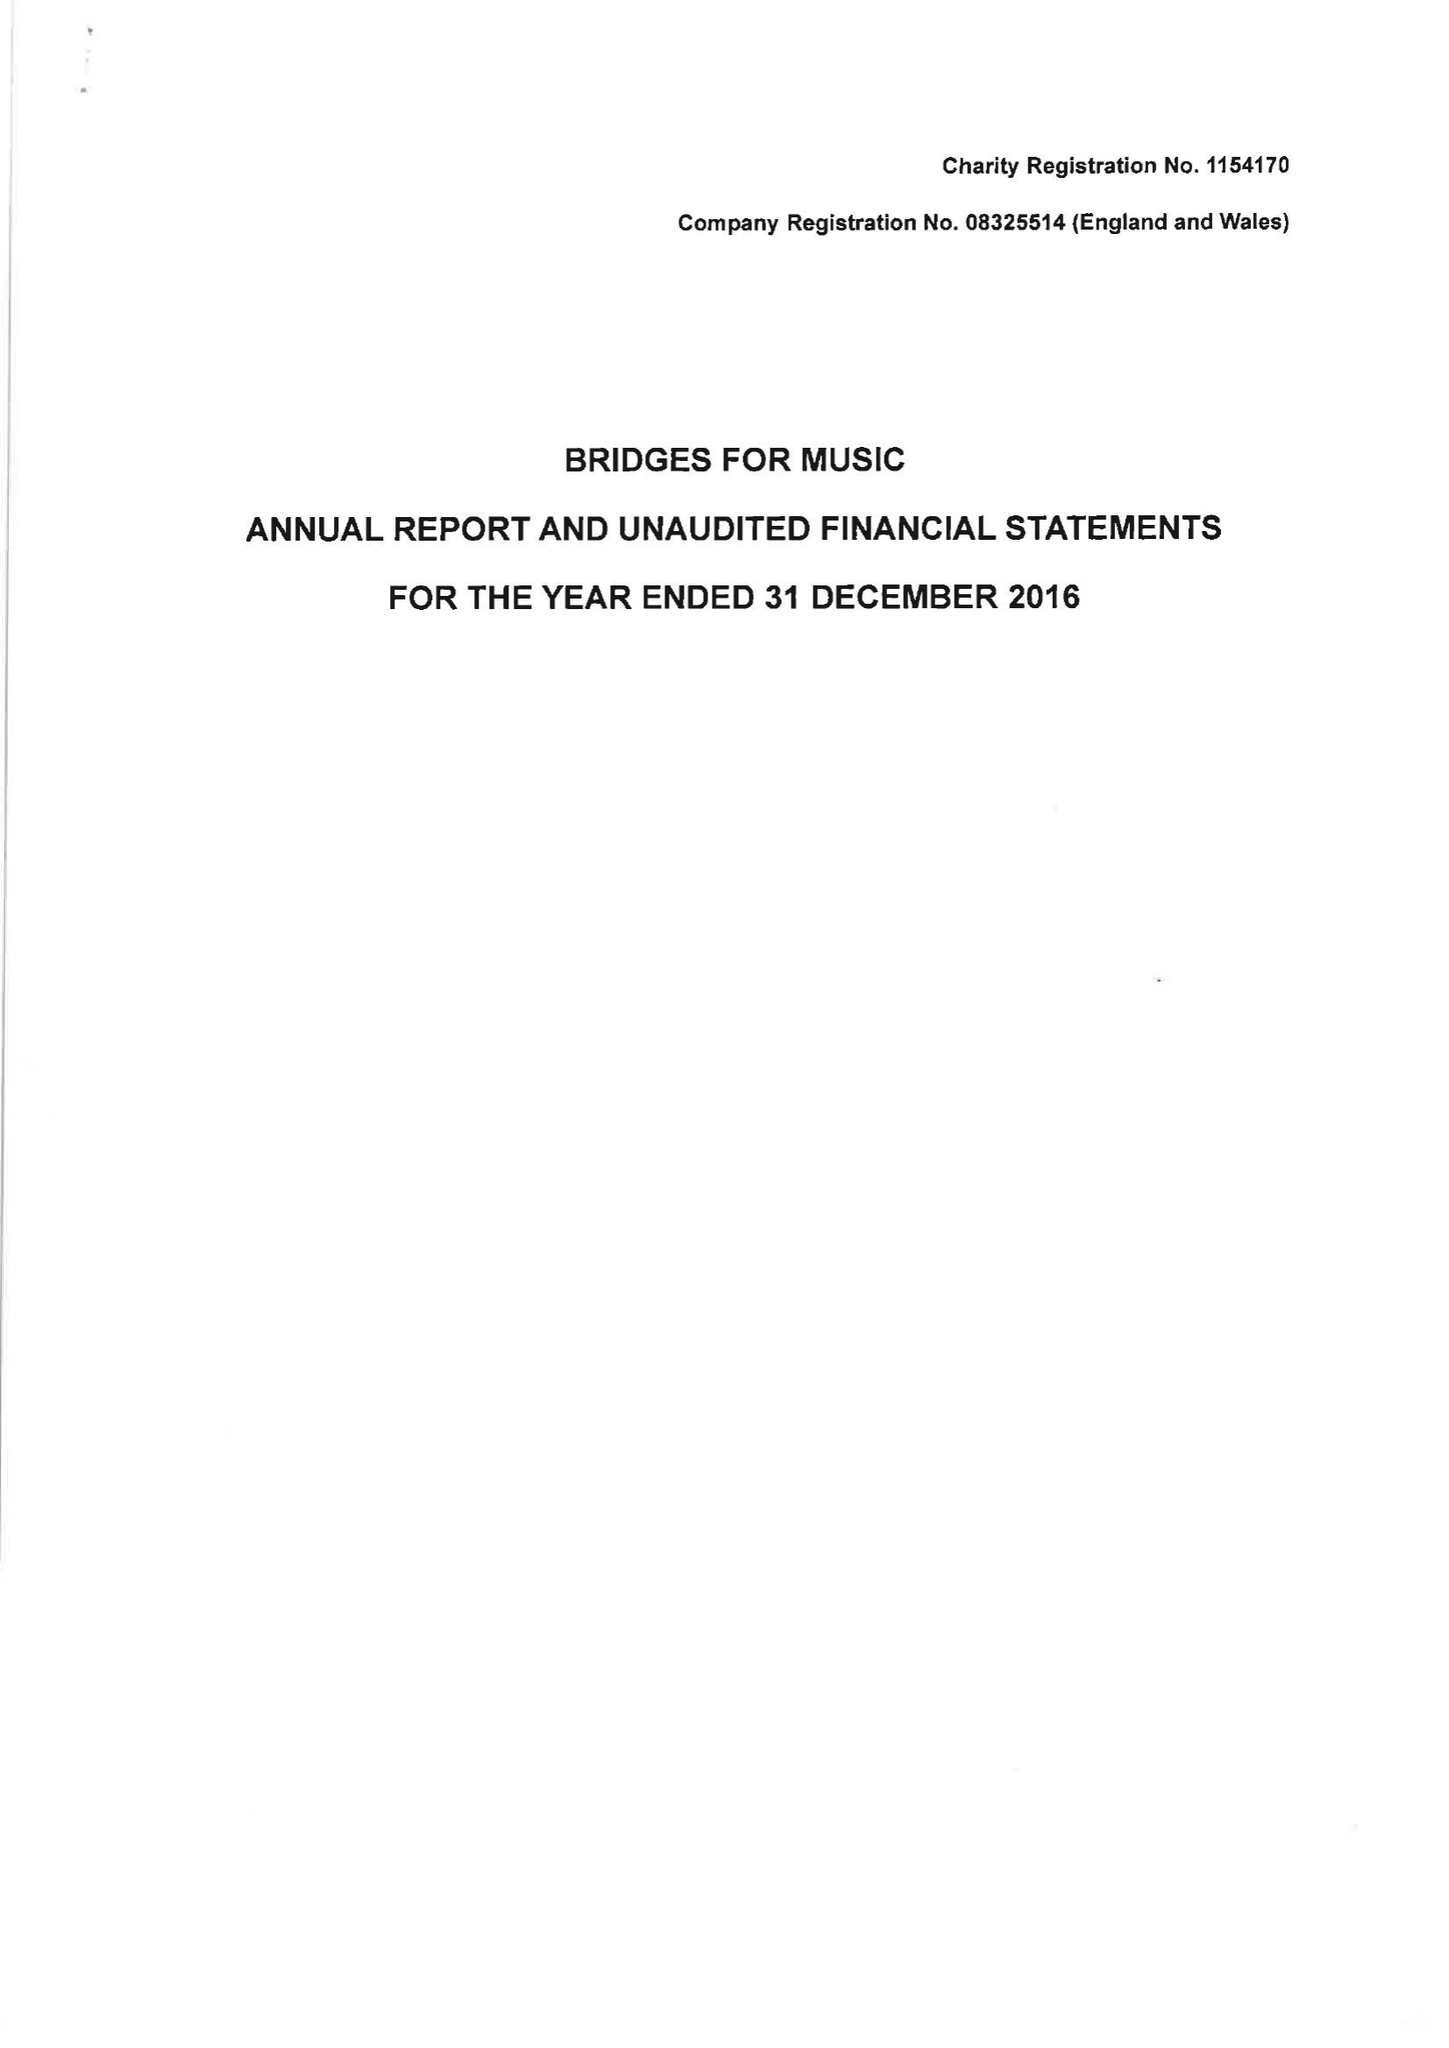What is the value for the charity_name?
Answer the question using a single word or phrase. Bridges For Music 